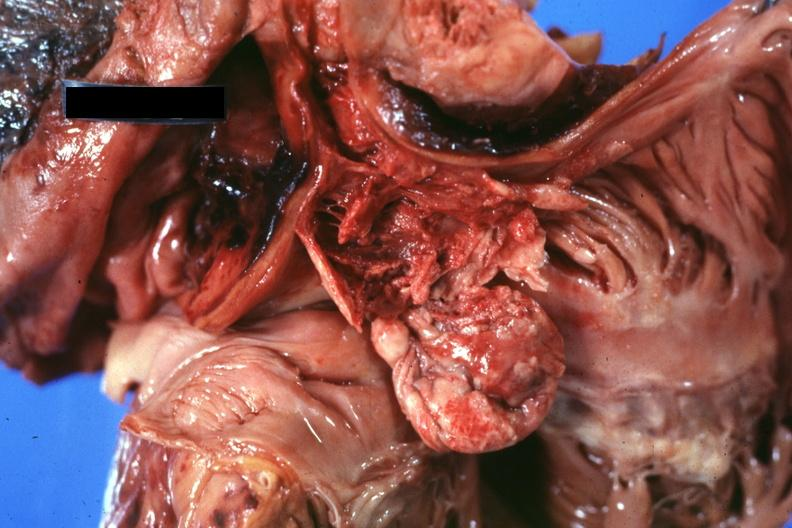what is present?
Answer the question using a single word or phrase. Malignant thymoma 